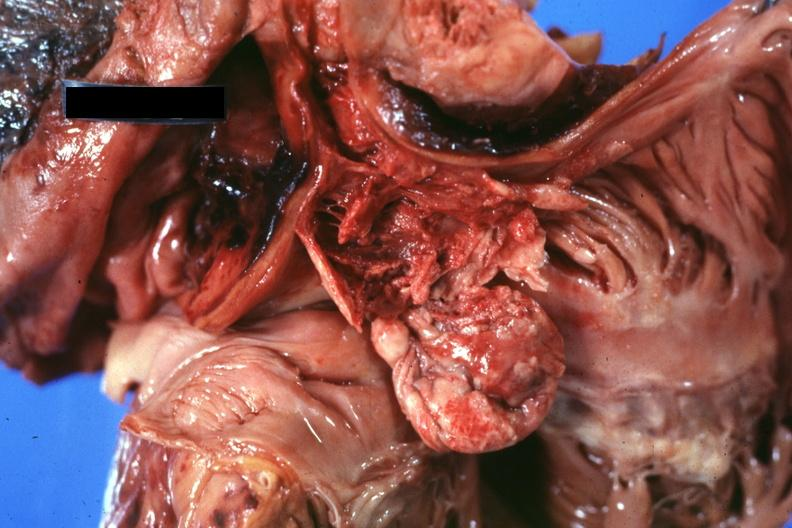what is present?
Answer the question using a single word or phrase. Malignant thymoma 